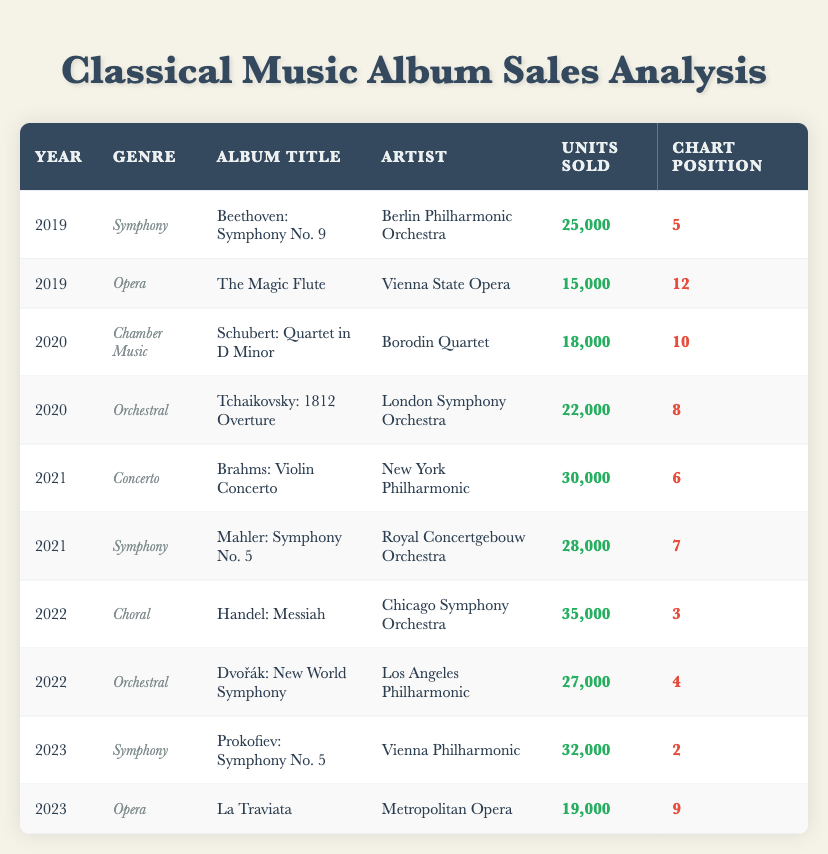What is the total number of units sold for albums in the Symphony genre? The Symphony genre has 3 entries in the table. The units sold for these albums are: 25,000 (2019), 28,000 (2021), and 32,000 (2023). Adding these gives 25,000 + 28,000 + 32,000 = 85,000.
Answer: 85,000 Which album had the highest units sold in the year 2022? In 2022, there are two albums listed: "Handel: Messiah" with 35,000 units sold and "Dvořák: New World Symphony" with 27,000 units sold. The album with the higher sales is "Handel: Messiah" with 35,000.
Answer: Handel: Messiah Did the album "La Traviata" sell more or less than the album "The Magic Flute"? "La Traviata" sold 19,000 units, and "The Magic Flute" sold 15,000 units. Since 19,000 is greater than 15,000, "La Traviata" sold more.
Answer: More What is the average number of units sold for albums in the Orchestral genre over the years listed? There are 2 Orchestral albums with units sold of 22,000 (2020) and 27,000 (2022). To find the average, sum these values (22,000 + 27,000 = 49,000) and divide by the number of albums (2). The average is 49,000 / 2 = 24,500.
Answer: 24,500 Which year had the highest sales for a single album? The highest units sold for a single album in the table is 35,000 for "Handel: Messiah" released in 2022. Comparing this with the other albums, none exceed this figure. Thus, 2022 had the highest sales for a single album.
Answer: 2022 Which artist had the most successful album in terms of chart position in 2021? In 2021, two albums are listed: "Brahms: Violin Concerto" by the New York Philharmonic at chart position 6 and "Mahler: Symphony No. 5" by the Royal Concertgebouw Orchestra at chart position 7. The lower the number, the better the position, therefore "Brahms: Violin Concerto" is the most successful.
Answer: New York Philharmonic Are there any albums in the table with units sold greater than 30,000? Examining the units sold, "Brahms: Violin Concerto" (30,000) and "Handel: Messiah" (35,000) have unit sales equal to or greater than 30,000. Thus, there are albums that meet the criteria.
Answer: Yes What is the difference in units sold between the highest and lowest selling albums in 2020? In 2020, the albums are "Schubert: Quartet in D Minor" (18,000 units) and "Tchaikovsky: 1812 Overture" (22,000 units). The difference is calculated as 22,000 - 18,000 = 4,000.
Answer: 4,000 